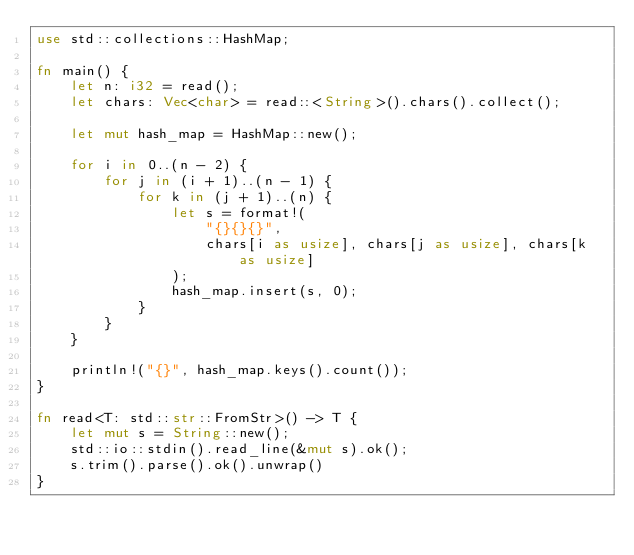<code> <loc_0><loc_0><loc_500><loc_500><_Rust_>use std::collections::HashMap;

fn main() {
    let n: i32 = read();
    let chars: Vec<char> = read::<String>().chars().collect();

    let mut hash_map = HashMap::new();

    for i in 0..(n - 2) {
        for j in (i + 1)..(n - 1) {
            for k in (j + 1)..(n) {
                let s = format!(
                    "{}{}{}",
                    chars[i as usize], chars[j as usize], chars[k as usize]
                );
                hash_map.insert(s, 0);
            }
        }
    }

    println!("{}", hash_map.keys().count());
}

fn read<T: std::str::FromStr>() -> T {
    let mut s = String::new();
    std::io::stdin().read_line(&mut s).ok();
    s.trim().parse().ok().unwrap()
}

</code> 